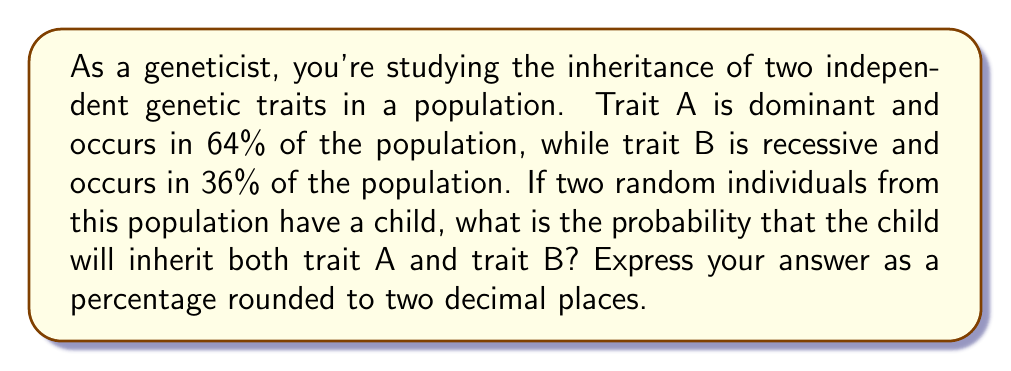Provide a solution to this math problem. To solve this problem, we need to follow these steps:

1) First, let's calculate the probabilities for each trait:

   For trait A (dominant):
   - Frequency of trait A in population = 64% = 0.64
   - Probability of inheriting trait A = $1 - (1-0.64)^2 = 1 - 0.36^2 = 0.8704$

   This is because the child will not inherit trait A only if both parents don't have it.

   For trait B (recessive):
   - Frequency of trait B in population = 36% = 0.36
   - Probability of inheriting trait B = $0.36^2 = 0.1296$

   This is because the child will inherit trait B only if both parents have it.

2) Since the traits are independent, we can multiply these probabilities:

   $$P(\text{both A and B}) = P(\text{A}) \times P(\text{B}) = 0.8704 \times 0.1296 = 0.1128$$

3) Convert to a percentage:

   $$0.1128 \times 100 = 11.28\%$$

4) Rounding to two decimal places:

   $$11.28\% \approx 11.28\%$$

Therefore, the probability that the child will inherit both trait A and trait B is approximately 11.28%.
Answer: 11.28% 